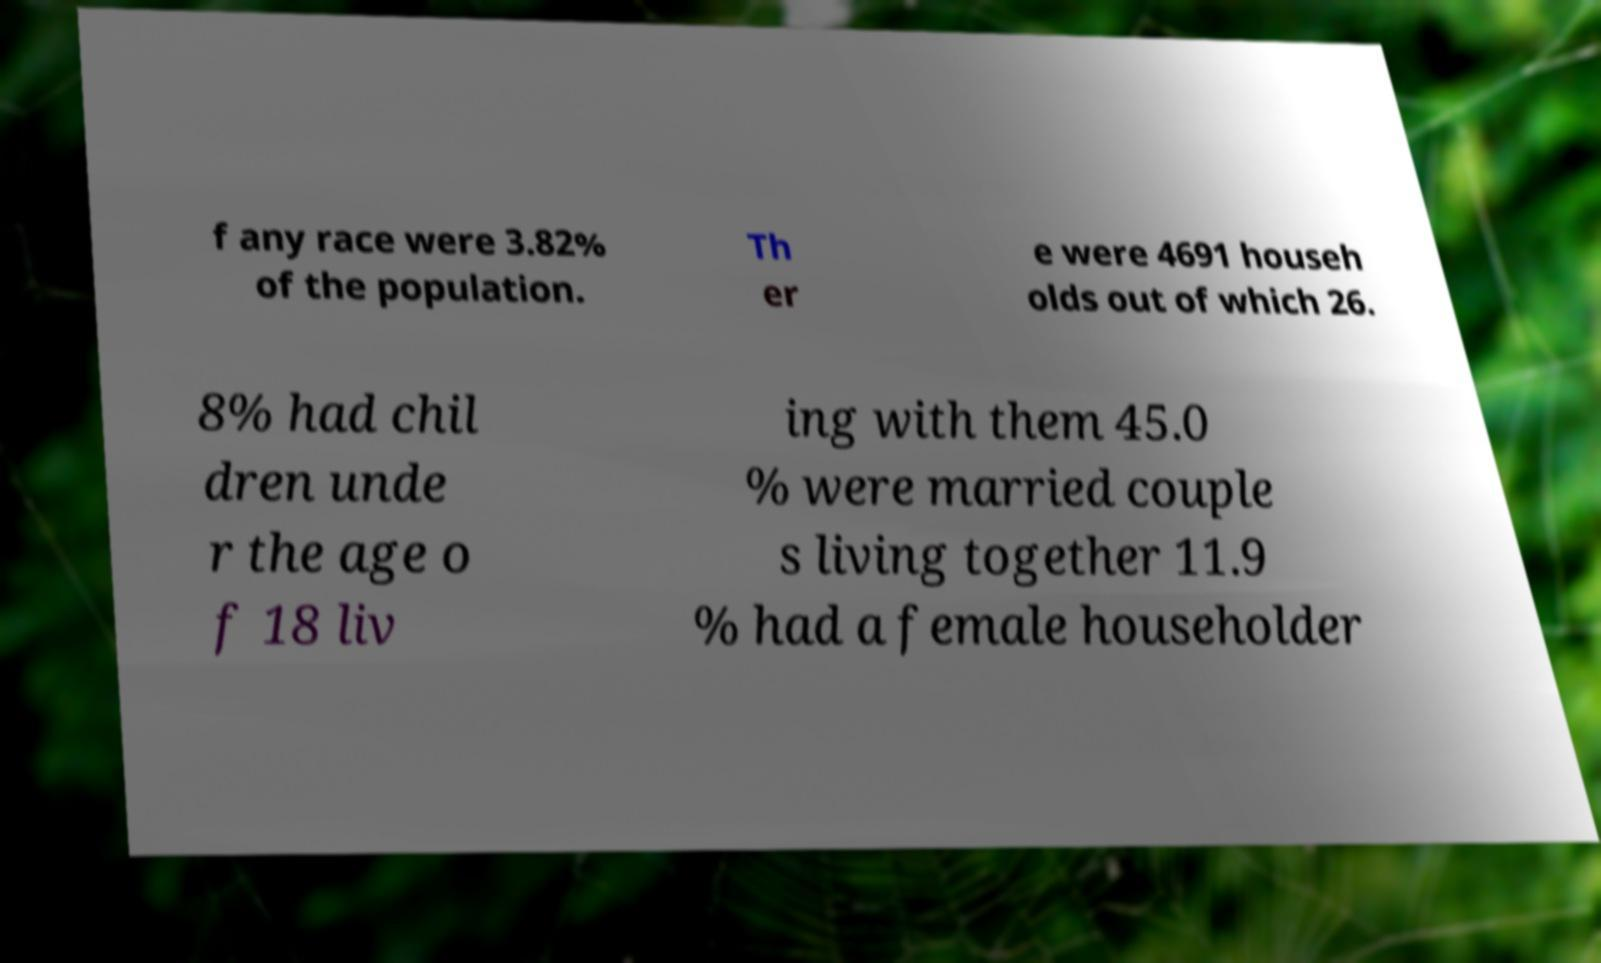Can you read and provide the text displayed in the image?This photo seems to have some interesting text. Can you extract and type it out for me? f any race were 3.82% of the population. Th er e were 4691 househ olds out of which 26. 8% had chil dren unde r the age o f 18 liv ing with them 45.0 % were married couple s living together 11.9 % had a female householder 